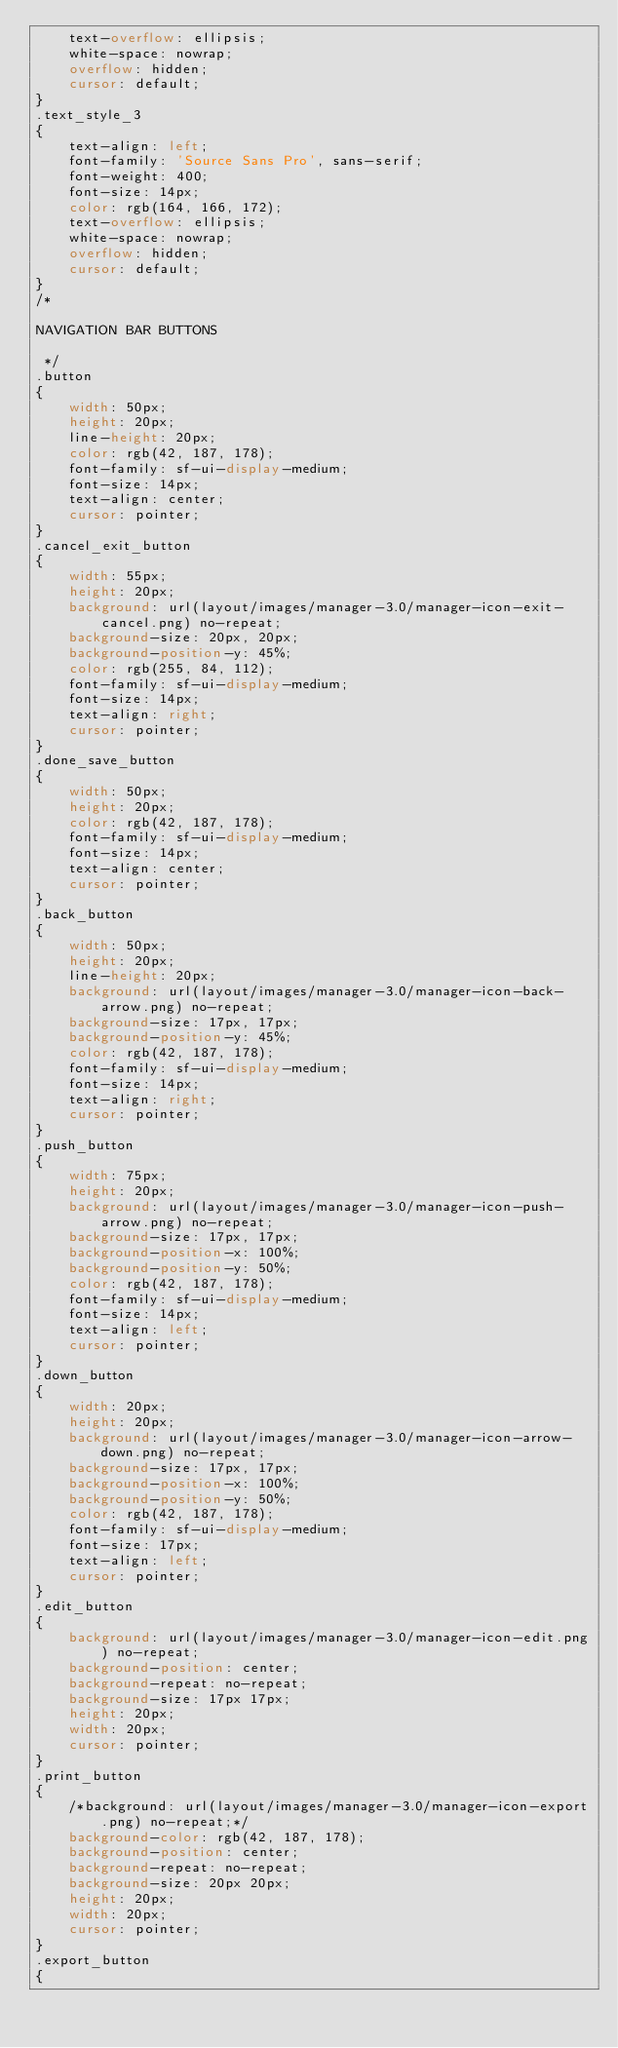<code> <loc_0><loc_0><loc_500><loc_500><_CSS_>    text-overflow: ellipsis;
    white-space: nowrap;
    overflow: hidden;
    cursor: default;
}
.text_style_3
{
    text-align: left;
    font-family: 'Source Sans Pro', sans-serif;
    font-weight: 400;
    font-size: 14px;
    color: rgb(164, 166, 172);
    text-overflow: ellipsis;
    white-space: nowrap;
    overflow: hidden;
    cursor: default;
}
/*

NAVIGATION BAR BUTTONS

 */
.button
{
    width: 50px;
    height: 20px;
    line-height: 20px;
    color: rgb(42, 187, 178);
    font-family: sf-ui-display-medium;
    font-size: 14px;
    text-align: center;
    cursor: pointer;
}
.cancel_exit_button
{
    width: 55px;
    height: 20px;
    background: url(layout/images/manager-3.0/manager-icon-exit-cancel.png) no-repeat;
    background-size: 20px, 20px;
    background-position-y: 45%;
    color: rgb(255, 84, 112);
    font-family: sf-ui-display-medium;
    font-size: 14px;
    text-align: right;
    cursor: pointer;
}
.done_save_button
{
    width: 50px;
    height: 20px;
    color: rgb(42, 187, 178);
    font-family: sf-ui-display-medium;
    font-size: 14px;
    text-align: center;
    cursor: pointer;
}
.back_button
{
    width: 50px;
    height: 20px;
    line-height: 20px;
    background: url(layout/images/manager-3.0/manager-icon-back-arrow.png) no-repeat;
    background-size: 17px, 17px;
    background-position-y: 45%;
    color: rgb(42, 187, 178);
    font-family: sf-ui-display-medium;
    font-size: 14px;
    text-align: right;
    cursor: pointer;
}
.push_button
{
    width: 75px;
    height: 20px;
    background: url(layout/images/manager-3.0/manager-icon-push-arrow.png) no-repeat;
    background-size: 17px, 17px;
    background-position-x: 100%;
    background-position-y: 50%;
    color: rgb(42, 187, 178);
    font-family: sf-ui-display-medium;
    font-size: 14px;
    text-align: left;
    cursor: pointer;
}
.down_button
{
    width: 20px;
    height: 20px;
    background: url(layout/images/manager-3.0/manager-icon-arrow-down.png) no-repeat;
    background-size: 17px, 17px;
    background-position-x: 100%;
    background-position-y: 50%;
    color: rgb(42, 187, 178);
    font-family: sf-ui-display-medium;
    font-size: 17px;
    text-align: left;
    cursor: pointer;
}
.edit_button
{
    background: url(layout/images/manager-3.0/manager-icon-edit.png) no-repeat;
    background-position: center;
    background-repeat: no-repeat;
    background-size: 17px 17px;
    height: 20px;
    width: 20px;
    cursor: pointer;
}
.print_button
{
    /*background: url(layout/images/manager-3.0/manager-icon-export.png) no-repeat;*/
    background-color: rgb(42, 187, 178);
    background-position: center;
    background-repeat: no-repeat;
    background-size: 20px 20px;
    height: 20px;
    width: 20px;
    cursor: pointer;
}
.export_button
{</code> 